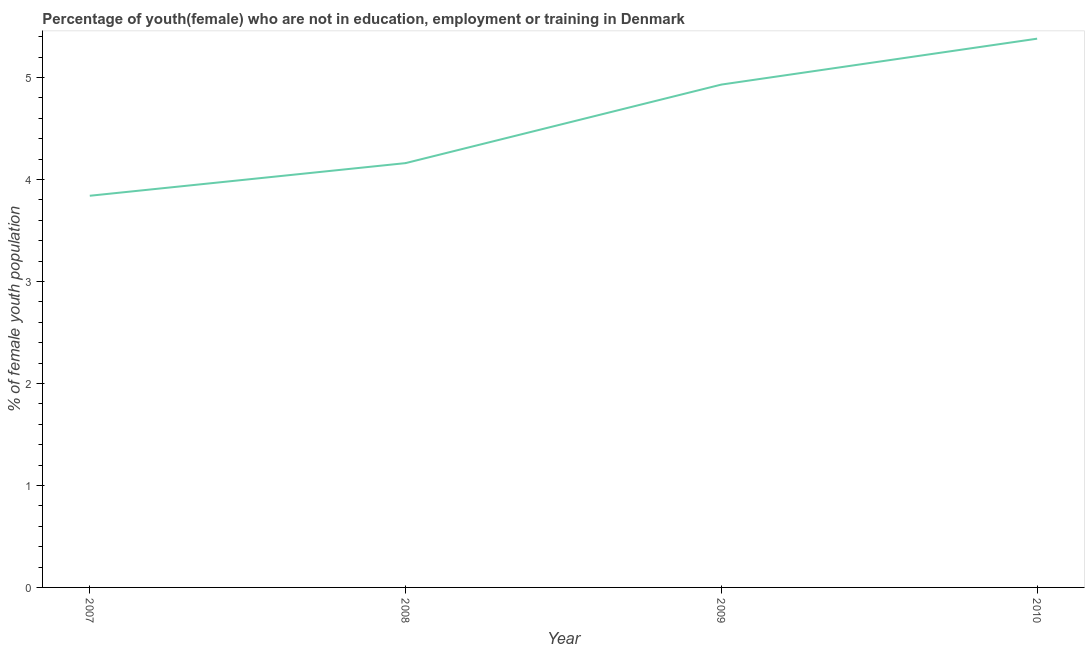What is the unemployed female youth population in 2008?
Give a very brief answer. 4.16. Across all years, what is the maximum unemployed female youth population?
Your answer should be compact. 5.38. Across all years, what is the minimum unemployed female youth population?
Offer a very short reply. 3.84. In which year was the unemployed female youth population maximum?
Your answer should be compact. 2010. What is the sum of the unemployed female youth population?
Your answer should be very brief. 18.31. What is the difference between the unemployed female youth population in 2007 and 2008?
Make the answer very short. -0.32. What is the average unemployed female youth population per year?
Offer a terse response. 4.58. What is the median unemployed female youth population?
Provide a short and direct response. 4.54. Do a majority of the years between 2009 and 2008 (inclusive) have unemployed female youth population greater than 3 %?
Give a very brief answer. No. What is the ratio of the unemployed female youth population in 2007 to that in 2008?
Make the answer very short. 0.92. What is the difference between the highest and the second highest unemployed female youth population?
Give a very brief answer. 0.45. What is the difference between the highest and the lowest unemployed female youth population?
Give a very brief answer. 1.54. How many years are there in the graph?
Provide a short and direct response. 4. What is the difference between two consecutive major ticks on the Y-axis?
Your answer should be compact. 1. Does the graph contain any zero values?
Provide a short and direct response. No. Does the graph contain grids?
Provide a succinct answer. No. What is the title of the graph?
Make the answer very short. Percentage of youth(female) who are not in education, employment or training in Denmark. What is the label or title of the Y-axis?
Ensure brevity in your answer.  % of female youth population. What is the % of female youth population of 2007?
Offer a very short reply. 3.84. What is the % of female youth population in 2008?
Ensure brevity in your answer.  4.16. What is the % of female youth population of 2009?
Give a very brief answer. 4.93. What is the % of female youth population of 2010?
Keep it short and to the point. 5.38. What is the difference between the % of female youth population in 2007 and 2008?
Make the answer very short. -0.32. What is the difference between the % of female youth population in 2007 and 2009?
Provide a succinct answer. -1.09. What is the difference between the % of female youth population in 2007 and 2010?
Make the answer very short. -1.54. What is the difference between the % of female youth population in 2008 and 2009?
Give a very brief answer. -0.77. What is the difference between the % of female youth population in 2008 and 2010?
Your answer should be compact. -1.22. What is the difference between the % of female youth population in 2009 and 2010?
Ensure brevity in your answer.  -0.45. What is the ratio of the % of female youth population in 2007 to that in 2008?
Your answer should be very brief. 0.92. What is the ratio of the % of female youth population in 2007 to that in 2009?
Ensure brevity in your answer.  0.78. What is the ratio of the % of female youth population in 2007 to that in 2010?
Offer a very short reply. 0.71. What is the ratio of the % of female youth population in 2008 to that in 2009?
Your response must be concise. 0.84. What is the ratio of the % of female youth population in 2008 to that in 2010?
Your answer should be very brief. 0.77. What is the ratio of the % of female youth population in 2009 to that in 2010?
Your response must be concise. 0.92. 